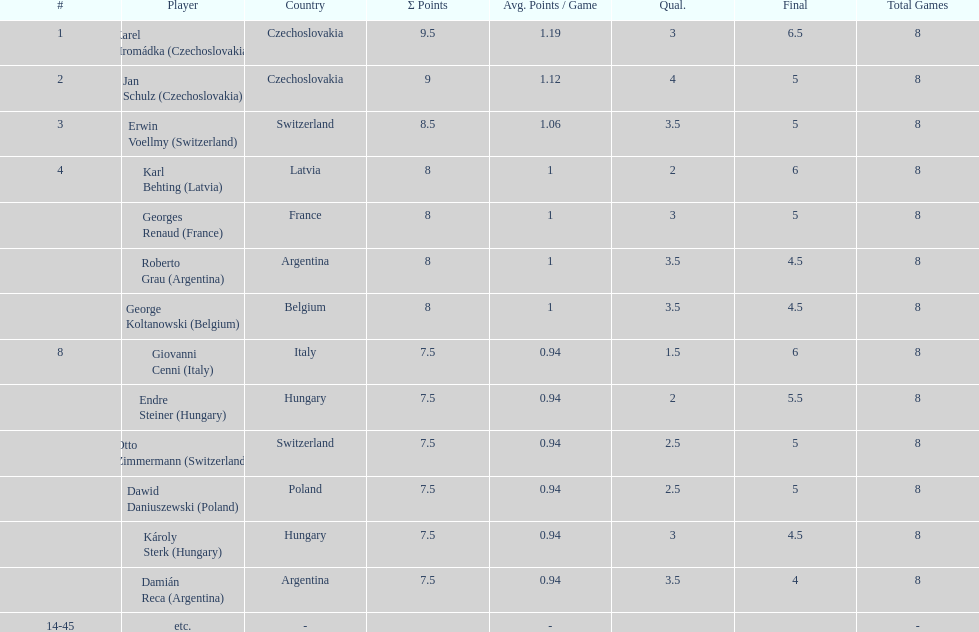Immediately above jan schulz, who is the ranked player? Karel Hromádka. 